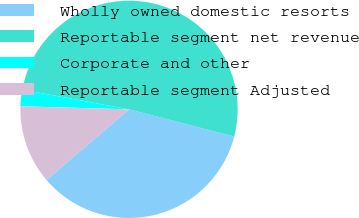<chart> <loc_0><loc_0><loc_500><loc_500><pie_chart><fcel>Wholly owned domestic resorts<fcel>Reportable segment net revenue<fcel>Corporate and other<fcel>Reportable segment Adjusted<nl><fcel>34.7%<fcel>51.12%<fcel>2.46%<fcel>11.72%<nl></chart> 